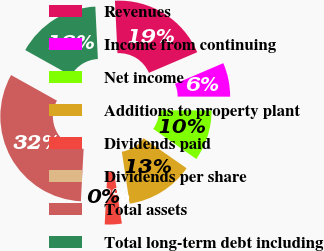Convert chart to OTSL. <chart><loc_0><loc_0><loc_500><loc_500><pie_chart><fcel>Revenues<fcel>Income from continuing<fcel>Net income<fcel>Additions to property plant<fcel>Dividends paid<fcel>Dividends per share<fcel>Total assets<fcel>Total long-term debt including<nl><fcel>19.35%<fcel>6.45%<fcel>9.68%<fcel>12.9%<fcel>3.23%<fcel>0.0%<fcel>32.26%<fcel>16.13%<nl></chart> 